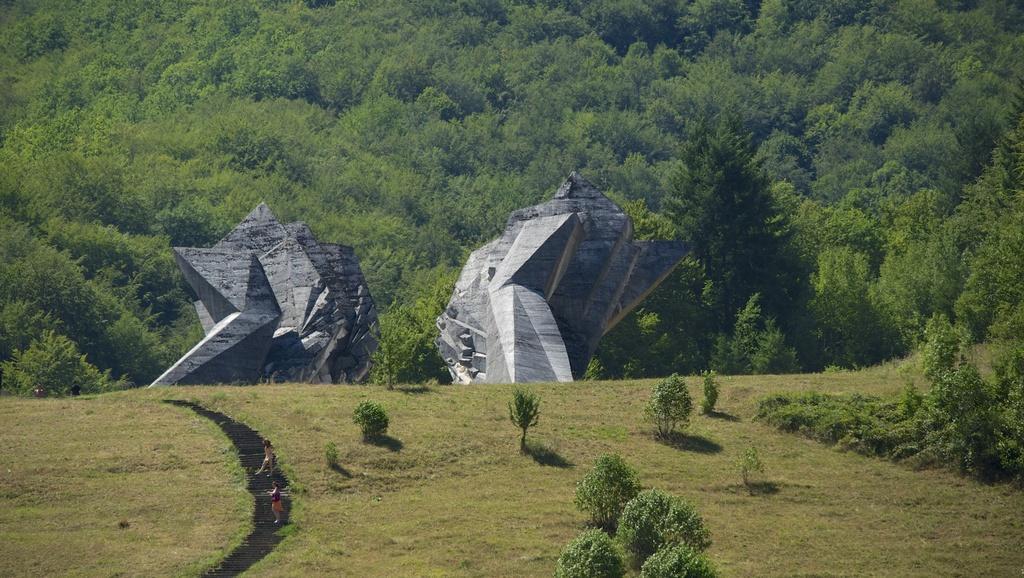Can you describe this image briefly? In this image I can see two persons standing, background I can see few huge carved rocks and I can see the trees in green color. 